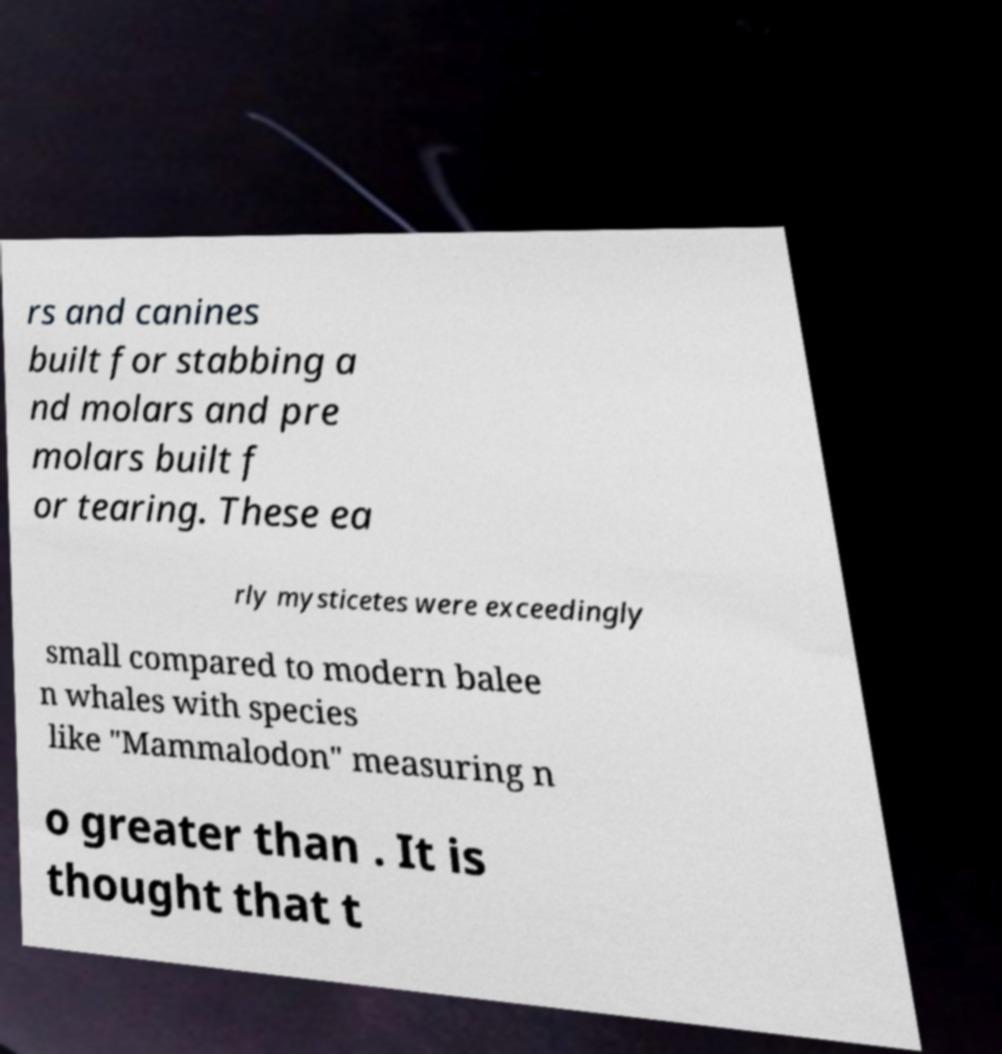Please identify and transcribe the text found in this image. rs and canines built for stabbing a nd molars and pre molars built f or tearing. These ea rly mysticetes were exceedingly small compared to modern balee n whales with species like "Mammalodon" measuring n o greater than . It is thought that t 